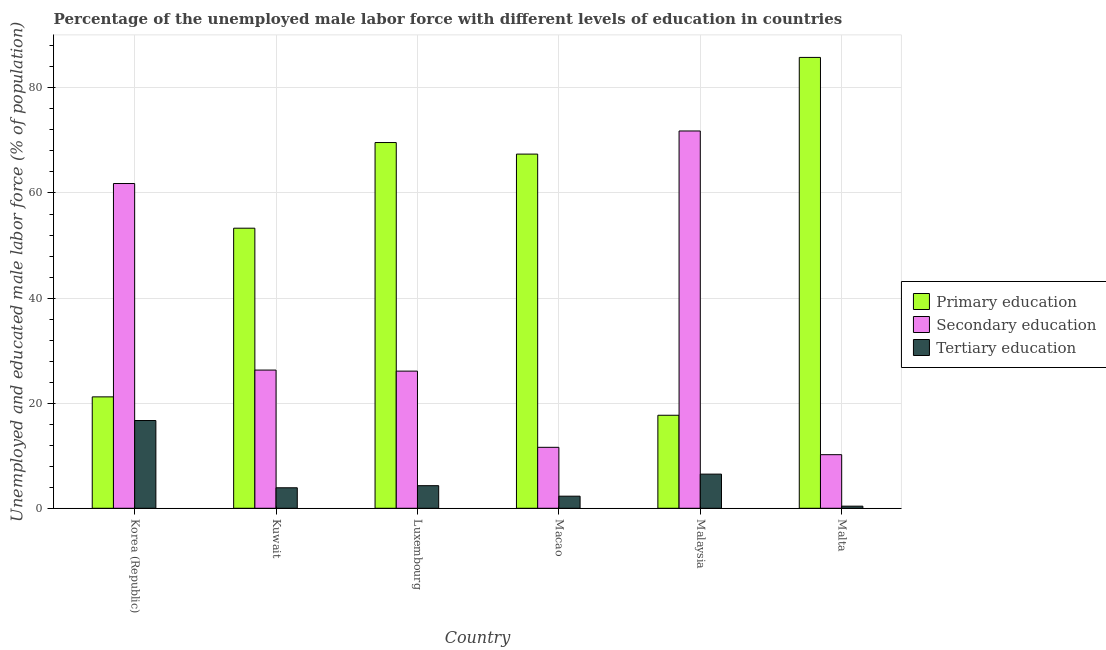How many different coloured bars are there?
Keep it short and to the point. 3. How many groups of bars are there?
Make the answer very short. 6. How many bars are there on the 1st tick from the left?
Your answer should be very brief. 3. What is the label of the 4th group of bars from the left?
Your answer should be compact. Macao. What is the percentage of male labor force who received secondary education in Malaysia?
Your response must be concise. 71.8. Across all countries, what is the maximum percentage of male labor force who received primary education?
Provide a succinct answer. 85.8. Across all countries, what is the minimum percentage of male labor force who received primary education?
Ensure brevity in your answer.  17.7. In which country was the percentage of male labor force who received tertiary education maximum?
Make the answer very short. Korea (Republic). In which country was the percentage of male labor force who received primary education minimum?
Make the answer very short. Malaysia. What is the total percentage of male labor force who received primary education in the graph?
Your response must be concise. 315. What is the difference between the percentage of male labor force who received tertiary education in Korea (Republic) and that in Malta?
Offer a terse response. 16.3. What is the difference between the percentage of male labor force who received tertiary education in Luxembourg and the percentage of male labor force who received secondary education in Korea (Republic)?
Ensure brevity in your answer.  -57.5. What is the average percentage of male labor force who received secondary education per country?
Your answer should be very brief. 34.63. What is the difference between the percentage of male labor force who received secondary education and percentage of male labor force who received primary education in Malta?
Keep it short and to the point. -75.6. What is the ratio of the percentage of male labor force who received secondary education in Macao to that in Malaysia?
Give a very brief answer. 0.16. Is the percentage of male labor force who received secondary education in Korea (Republic) less than that in Malaysia?
Your answer should be compact. Yes. Is the difference between the percentage of male labor force who received tertiary education in Kuwait and Malaysia greater than the difference between the percentage of male labor force who received secondary education in Kuwait and Malaysia?
Your answer should be very brief. Yes. What is the difference between the highest and the second highest percentage of male labor force who received primary education?
Make the answer very short. 16.2. What is the difference between the highest and the lowest percentage of male labor force who received primary education?
Offer a very short reply. 68.1. Is the sum of the percentage of male labor force who received tertiary education in Luxembourg and Malta greater than the maximum percentage of male labor force who received primary education across all countries?
Keep it short and to the point. No. What does the 3rd bar from the right in Malta represents?
Your answer should be compact. Primary education. How many bars are there?
Your answer should be very brief. 18. Are all the bars in the graph horizontal?
Keep it short and to the point. No. How many countries are there in the graph?
Your answer should be very brief. 6. What is the difference between two consecutive major ticks on the Y-axis?
Ensure brevity in your answer.  20. Are the values on the major ticks of Y-axis written in scientific E-notation?
Offer a very short reply. No. What is the title of the graph?
Provide a succinct answer. Percentage of the unemployed male labor force with different levels of education in countries. What is the label or title of the X-axis?
Offer a very short reply. Country. What is the label or title of the Y-axis?
Your answer should be very brief. Unemployed and educated male labor force (% of population). What is the Unemployed and educated male labor force (% of population) of Primary education in Korea (Republic)?
Offer a very short reply. 21.2. What is the Unemployed and educated male labor force (% of population) of Secondary education in Korea (Republic)?
Give a very brief answer. 61.8. What is the Unemployed and educated male labor force (% of population) of Tertiary education in Korea (Republic)?
Offer a very short reply. 16.7. What is the Unemployed and educated male labor force (% of population) of Primary education in Kuwait?
Give a very brief answer. 53.3. What is the Unemployed and educated male labor force (% of population) of Secondary education in Kuwait?
Ensure brevity in your answer.  26.3. What is the Unemployed and educated male labor force (% of population) in Tertiary education in Kuwait?
Make the answer very short. 3.9. What is the Unemployed and educated male labor force (% of population) of Primary education in Luxembourg?
Provide a succinct answer. 69.6. What is the Unemployed and educated male labor force (% of population) in Secondary education in Luxembourg?
Your answer should be very brief. 26.1. What is the Unemployed and educated male labor force (% of population) in Tertiary education in Luxembourg?
Your answer should be compact. 4.3. What is the Unemployed and educated male labor force (% of population) in Primary education in Macao?
Your response must be concise. 67.4. What is the Unemployed and educated male labor force (% of population) in Secondary education in Macao?
Ensure brevity in your answer.  11.6. What is the Unemployed and educated male labor force (% of population) in Tertiary education in Macao?
Ensure brevity in your answer.  2.3. What is the Unemployed and educated male labor force (% of population) of Primary education in Malaysia?
Give a very brief answer. 17.7. What is the Unemployed and educated male labor force (% of population) in Secondary education in Malaysia?
Offer a very short reply. 71.8. What is the Unemployed and educated male labor force (% of population) of Tertiary education in Malaysia?
Ensure brevity in your answer.  6.5. What is the Unemployed and educated male labor force (% of population) in Primary education in Malta?
Make the answer very short. 85.8. What is the Unemployed and educated male labor force (% of population) of Secondary education in Malta?
Offer a very short reply. 10.2. What is the Unemployed and educated male labor force (% of population) of Tertiary education in Malta?
Make the answer very short. 0.4. Across all countries, what is the maximum Unemployed and educated male labor force (% of population) of Primary education?
Offer a very short reply. 85.8. Across all countries, what is the maximum Unemployed and educated male labor force (% of population) in Secondary education?
Your answer should be compact. 71.8. Across all countries, what is the maximum Unemployed and educated male labor force (% of population) in Tertiary education?
Make the answer very short. 16.7. Across all countries, what is the minimum Unemployed and educated male labor force (% of population) in Primary education?
Your answer should be very brief. 17.7. Across all countries, what is the minimum Unemployed and educated male labor force (% of population) in Secondary education?
Provide a short and direct response. 10.2. Across all countries, what is the minimum Unemployed and educated male labor force (% of population) in Tertiary education?
Your answer should be very brief. 0.4. What is the total Unemployed and educated male labor force (% of population) of Primary education in the graph?
Make the answer very short. 315. What is the total Unemployed and educated male labor force (% of population) of Secondary education in the graph?
Your response must be concise. 207.8. What is the total Unemployed and educated male labor force (% of population) of Tertiary education in the graph?
Offer a very short reply. 34.1. What is the difference between the Unemployed and educated male labor force (% of population) in Primary education in Korea (Republic) and that in Kuwait?
Keep it short and to the point. -32.1. What is the difference between the Unemployed and educated male labor force (% of population) in Secondary education in Korea (Republic) and that in Kuwait?
Keep it short and to the point. 35.5. What is the difference between the Unemployed and educated male labor force (% of population) in Primary education in Korea (Republic) and that in Luxembourg?
Give a very brief answer. -48.4. What is the difference between the Unemployed and educated male labor force (% of population) in Secondary education in Korea (Republic) and that in Luxembourg?
Ensure brevity in your answer.  35.7. What is the difference between the Unemployed and educated male labor force (% of population) of Tertiary education in Korea (Republic) and that in Luxembourg?
Your response must be concise. 12.4. What is the difference between the Unemployed and educated male labor force (% of population) in Primary education in Korea (Republic) and that in Macao?
Provide a succinct answer. -46.2. What is the difference between the Unemployed and educated male labor force (% of population) in Secondary education in Korea (Republic) and that in Macao?
Give a very brief answer. 50.2. What is the difference between the Unemployed and educated male labor force (% of population) in Tertiary education in Korea (Republic) and that in Macao?
Provide a short and direct response. 14.4. What is the difference between the Unemployed and educated male labor force (% of population) of Primary education in Korea (Republic) and that in Malaysia?
Offer a very short reply. 3.5. What is the difference between the Unemployed and educated male labor force (% of population) of Secondary education in Korea (Republic) and that in Malaysia?
Offer a terse response. -10. What is the difference between the Unemployed and educated male labor force (% of population) of Tertiary education in Korea (Republic) and that in Malaysia?
Your answer should be compact. 10.2. What is the difference between the Unemployed and educated male labor force (% of population) of Primary education in Korea (Republic) and that in Malta?
Offer a very short reply. -64.6. What is the difference between the Unemployed and educated male labor force (% of population) of Secondary education in Korea (Republic) and that in Malta?
Offer a very short reply. 51.6. What is the difference between the Unemployed and educated male labor force (% of population) in Primary education in Kuwait and that in Luxembourg?
Provide a short and direct response. -16.3. What is the difference between the Unemployed and educated male labor force (% of population) in Secondary education in Kuwait and that in Luxembourg?
Offer a very short reply. 0.2. What is the difference between the Unemployed and educated male labor force (% of population) of Primary education in Kuwait and that in Macao?
Provide a short and direct response. -14.1. What is the difference between the Unemployed and educated male labor force (% of population) in Secondary education in Kuwait and that in Macao?
Give a very brief answer. 14.7. What is the difference between the Unemployed and educated male labor force (% of population) of Primary education in Kuwait and that in Malaysia?
Make the answer very short. 35.6. What is the difference between the Unemployed and educated male labor force (% of population) in Secondary education in Kuwait and that in Malaysia?
Offer a very short reply. -45.5. What is the difference between the Unemployed and educated male labor force (% of population) in Primary education in Kuwait and that in Malta?
Offer a terse response. -32.5. What is the difference between the Unemployed and educated male labor force (% of population) of Primary education in Luxembourg and that in Malaysia?
Give a very brief answer. 51.9. What is the difference between the Unemployed and educated male labor force (% of population) of Secondary education in Luxembourg and that in Malaysia?
Give a very brief answer. -45.7. What is the difference between the Unemployed and educated male labor force (% of population) in Primary education in Luxembourg and that in Malta?
Your answer should be compact. -16.2. What is the difference between the Unemployed and educated male labor force (% of population) in Secondary education in Luxembourg and that in Malta?
Keep it short and to the point. 15.9. What is the difference between the Unemployed and educated male labor force (% of population) in Tertiary education in Luxembourg and that in Malta?
Your answer should be very brief. 3.9. What is the difference between the Unemployed and educated male labor force (% of population) of Primary education in Macao and that in Malaysia?
Make the answer very short. 49.7. What is the difference between the Unemployed and educated male labor force (% of population) of Secondary education in Macao and that in Malaysia?
Make the answer very short. -60.2. What is the difference between the Unemployed and educated male labor force (% of population) of Primary education in Macao and that in Malta?
Keep it short and to the point. -18.4. What is the difference between the Unemployed and educated male labor force (% of population) of Tertiary education in Macao and that in Malta?
Keep it short and to the point. 1.9. What is the difference between the Unemployed and educated male labor force (% of population) in Primary education in Malaysia and that in Malta?
Provide a short and direct response. -68.1. What is the difference between the Unemployed and educated male labor force (% of population) of Secondary education in Malaysia and that in Malta?
Ensure brevity in your answer.  61.6. What is the difference between the Unemployed and educated male labor force (% of population) in Primary education in Korea (Republic) and the Unemployed and educated male labor force (% of population) in Secondary education in Kuwait?
Offer a terse response. -5.1. What is the difference between the Unemployed and educated male labor force (% of population) of Primary education in Korea (Republic) and the Unemployed and educated male labor force (% of population) of Tertiary education in Kuwait?
Your response must be concise. 17.3. What is the difference between the Unemployed and educated male labor force (% of population) of Secondary education in Korea (Republic) and the Unemployed and educated male labor force (% of population) of Tertiary education in Kuwait?
Keep it short and to the point. 57.9. What is the difference between the Unemployed and educated male labor force (% of population) of Secondary education in Korea (Republic) and the Unemployed and educated male labor force (% of population) of Tertiary education in Luxembourg?
Provide a succinct answer. 57.5. What is the difference between the Unemployed and educated male labor force (% of population) in Primary education in Korea (Republic) and the Unemployed and educated male labor force (% of population) in Secondary education in Macao?
Give a very brief answer. 9.6. What is the difference between the Unemployed and educated male labor force (% of population) in Primary education in Korea (Republic) and the Unemployed and educated male labor force (% of population) in Tertiary education in Macao?
Ensure brevity in your answer.  18.9. What is the difference between the Unemployed and educated male labor force (% of population) of Secondary education in Korea (Republic) and the Unemployed and educated male labor force (% of population) of Tertiary education in Macao?
Ensure brevity in your answer.  59.5. What is the difference between the Unemployed and educated male labor force (% of population) in Primary education in Korea (Republic) and the Unemployed and educated male labor force (% of population) in Secondary education in Malaysia?
Give a very brief answer. -50.6. What is the difference between the Unemployed and educated male labor force (% of population) in Primary education in Korea (Republic) and the Unemployed and educated male labor force (% of population) in Tertiary education in Malaysia?
Your answer should be very brief. 14.7. What is the difference between the Unemployed and educated male labor force (% of population) of Secondary education in Korea (Republic) and the Unemployed and educated male labor force (% of population) of Tertiary education in Malaysia?
Provide a succinct answer. 55.3. What is the difference between the Unemployed and educated male labor force (% of population) in Primary education in Korea (Republic) and the Unemployed and educated male labor force (% of population) in Tertiary education in Malta?
Offer a very short reply. 20.8. What is the difference between the Unemployed and educated male labor force (% of population) of Secondary education in Korea (Republic) and the Unemployed and educated male labor force (% of population) of Tertiary education in Malta?
Ensure brevity in your answer.  61.4. What is the difference between the Unemployed and educated male labor force (% of population) of Primary education in Kuwait and the Unemployed and educated male labor force (% of population) of Secondary education in Luxembourg?
Give a very brief answer. 27.2. What is the difference between the Unemployed and educated male labor force (% of population) of Secondary education in Kuwait and the Unemployed and educated male labor force (% of population) of Tertiary education in Luxembourg?
Give a very brief answer. 22. What is the difference between the Unemployed and educated male labor force (% of population) in Primary education in Kuwait and the Unemployed and educated male labor force (% of population) in Secondary education in Macao?
Your answer should be compact. 41.7. What is the difference between the Unemployed and educated male labor force (% of population) of Primary education in Kuwait and the Unemployed and educated male labor force (% of population) of Secondary education in Malaysia?
Keep it short and to the point. -18.5. What is the difference between the Unemployed and educated male labor force (% of population) in Primary education in Kuwait and the Unemployed and educated male labor force (% of population) in Tertiary education in Malaysia?
Keep it short and to the point. 46.8. What is the difference between the Unemployed and educated male labor force (% of population) of Secondary education in Kuwait and the Unemployed and educated male labor force (% of population) of Tertiary education in Malaysia?
Offer a terse response. 19.8. What is the difference between the Unemployed and educated male labor force (% of population) of Primary education in Kuwait and the Unemployed and educated male labor force (% of population) of Secondary education in Malta?
Your answer should be compact. 43.1. What is the difference between the Unemployed and educated male labor force (% of population) of Primary education in Kuwait and the Unemployed and educated male labor force (% of population) of Tertiary education in Malta?
Make the answer very short. 52.9. What is the difference between the Unemployed and educated male labor force (% of population) of Secondary education in Kuwait and the Unemployed and educated male labor force (% of population) of Tertiary education in Malta?
Make the answer very short. 25.9. What is the difference between the Unemployed and educated male labor force (% of population) of Primary education in Luxembourg and the Unemployed and educated male labor force (% of population) of Secondary education in Macao?
Offer a terse response. 58. What is the difference between the Unemployed and educated male labor force (% of population) in Primary education in Luxembourg and the Unemployed and educated male labor force (% of population) in Tertiary education in Macao?
Offer a terse response. 67.3. What is the difference between the Unemployed and educated male labor force (% of population) of Secondary education in Luxembourg and the Unemployed and educated male labor force (% of population) of Tertiary education in Macao?
Offer a very short reply. 23.8. What is the difference between the Unemployed and educated male labor force (% of population) in Primary education in Luxembourg and the Unemployed and educated male labor force (% of population) in Secondary education in Malaysia?
Provide a succinct answer. -2.2. What is the difference between the Unemployed and educated male labor force (% of population) in Primary education in Luxembourg and the Unemployed and educated male labor force (% of population) in Tertiary education in Malaysia?
Ensure brevity in your answer.  63.1. What is the difference between the Unemployed and educated male labor force (% of population) in Secondary education in Luxembourg and the Unemployed and educated male labor force (% of population) in Tertiary education in Malaysia?
Your response must be concise. 19.6. What is the difference between the Unemployed and educated male labor force (% of population) in Primary education in Luxembourg and the Unemployed and educated male labor force (% of population) in Secondary education in Malta?
Provide a succinct answer. 59.4. What is the difference between the Unemployed and educated male labor force (% of population) in Primary education in Luxembourg and the Unemployed and educated male labor force (% of population) in Tertiary education in Malta?
Provide a short and direct response. 69.2. What is the difference between the Unemployed and educated male labor force (% of population) in Secondary education in Luxembourg and the Unemployed and educated male labor force (% of population) in Tertiary education in Malta?
Keep it short and to the point. 25.7. What is the difference between the Unemployed and educated male labor force (% of population) in Primary education in Macao and the Unemployed and educated male labor force (% of population) in Tertiary education in Malaysia?
Offer a very short reply. 60.9. What is the difference between the Unemployed and educated male labor force (% of population) of Primary education in Macao and the Unemployed and educated male labor force (% of population) of Secondary education in Malta?
Your answer should be compact. 57.2. What is the difference between the Unemployed and educated male labor force (% of population) of Secondary education in Malaysia and the Unemployed and educated male labor force (% of population) of Tertiary education in Malta?
Make the answer very short. 71.4. What is the average Unemployed and educated male labor force (% of population) of Primary education per country?
Make the answer very short. 52.5. What is the average Unemployed and educated male labor force (% of population) in Secondary education per country?
Offer a very short reply. 34.63. What is the average Unemployed and educated male labor force (% of population) of Tertiary education per country?
Your answer should be very brief. 5.68. What is the difference between the Unemployed and educated male labor force (% of population) in Primary education and Unemployed and educated male labor force (% of population) in Secondary education in Korea (Republic)?
Offer a very short reply. -40.6. What is the difference between the Unemployed and educated male labor force (% of population) in Secondary education and Unemployed and educated male labor force (% of population) in Tertiary education in Korea (Republic)?
Provide a short and direct response. 45.1. What is the difference between the Unemployed and educated male labor force (% of population) in Primary education and Unemployed and educated male labor force (% of population) in Tertiary education in Kuwait?
Provide a succinct answer. 49.4. What is the difference between the Unemployed and educated male labor force (% of population) in Secondary education and Unemployed and educated male labor force (% of population) in Tertiary education in Kuwait?
Your answer should be very brief. 22.4. What is the difference between the Unemployed and educated male labor force (% of population) in Primary education and Unemployed and educated male labor force (% of population) in Secondary education in Luxembourg?
Offer a terse response. 43.5. What is the difference between the Unemployed and educated male labor force (% of population) in Primary education and Unemployed and educated male labor force (% of population) in Tertiary education in Luxembourg?
Make the answer very short. 65.3. What is the difference between the Unemployed and educated male labor force (% of population) of Secondary education and Unemployed and educated male labor force (% of population) of Tertiary education in Luxembourg?
Make the answer very short. 21.8. What is the difference between the Unemployed and educated male labor force (% of population) of Primary education and Unemployed and educated male labor force (% of population) of Secondary education in Macao?
Give a very brief answer. 55.8. What is the difference between the Unemployed and educated male labor force (% of population) of Primary education and Unemployed and educated male labor force (% of population) of Tertiary education in Macao?
Your answer should be compact. 65.1. What is the difference between the Unemployed and educated male labor force (% of population) in Primary education and Unemployed and educated male labor force (% of population) in Secondary education in Malaysia?
Offer a terse response. -54.1. What is the difference between the Unemployed and educated male labor force (% of population) of Secondary education and Unemployed and educated male labor force (% of population) of Tertiary education in Malaysia?
Ensure brevity in your answer.  65.3. What is the difference between the Unemployed and educated male labor force (% of population) of Primary education and Unemployed and educated male labor force (% of population) of Secondary education in Malta?
Your answer should be very brief. 75.6. What is the difference between the Unemployed and educated male labor force (% of population) in Primary education and Unemployed and educated male labor force (% of population) in Tertiary education in Malta?
Offer a terse response. 85.4. What is the ratio of the Unemployed and educated male labor force (% of population) of Primary education in Korea (Republic) to that in Kuwait?
Ensure brevity in your answer.  0.4. What is the ratio of the Unemployed and educated male labor force (% of population) in Secondary education in Korea (Republic) to that in Kuwait?
Provide a succinct answer. 2.35. What is the ratio of the Unemployed and educated male labor force (% of population) of Tertiary education in Korea (Republic) to that in Kuwait?
Offer a very short reply. 4.28. What is the ratio of the Unemployed and educated male labor force (% of population) in Primary education in Korea (Republic) to that in Luxembourg?
Your response must be concise. 0.3. What is the ratio of the Unemployed and educated male labor force (% of population) in Secondary education in Korea (Republic) to that in Luxembourg?
Your answer should be compact. 2.37. What is the ratio of the Unemployed and educated male labor force (% of population) in Tertiary education in Korea (Republic) to that in Luxembourg?
Give a very brief answer. 3.88. What is the ratio of the Unemployed and educated male labor force (% of population) in Primary education in Korea (Republic) to that in Macao?
Ensure brevity in your answer.  0.31. What is the ratio of the Unemployed and educated male labor force (% of population) in Secondary education in Korea (Republic) to that in Macao?
Your answer should be very brief. 5.33. What is the ratio of the Unemployed and educated male labor force (% of population) in Tertiary education in Korea (Republic) to that in Macao?
Your answer should be compact. 7.26. What is the ratio of the Unemployed and educated male labor force (% of population) in Primary education in Korea (Republic) to that in Malaysia?
Make the answer very short. 1.2. What is the ratio of the Unemployed and educated male labor force (% of population) of Secondary education in Korea (Republic) to that in Malaysia?
Provide a succinct answer. 0.86. What is the ratio of the Unemployed and educated male labor force (% of population) of Tertiary education in Korea (Republic) to that in Malaysia?
Make the answer very short. 2.57. What is the ratio of the Unemployed and educated male labor force (% of population) of Primary education in Korea (Republic) to that in Malta?
Your answer should be compact. 0.25. What is the ratio of the Unemployed and educated male labor force (% of population) of Secondary education in Korea (Republic) to that in Malta?
Offer a terse response. 6.06. What is the ratio of the Unemployed and educated male labor force (% of population) in Tertiary education in Korea (Republic) to that in Malta?
Provide a succinct answer. 41.75. What is the ratio of the Unemployed and educated male labor force (% of population) of Primary education in Kuwait to that in Luxembourg?
Keep it short and to the point. 0.77. What is the ratio of the Unemployed and educated male labor force (% of population) in Secondary education in Kuwait to that in Luxembourg?
Make the answer very short. 1.01. What is the ratio of the Unemployed and educated male labor force (% of population) of Tertiary education in Kuwait to that in Luxembourg?
Ensure brevity in your answer.  0.91. What is the ratio of the Unemployed and educated male labor force (% of population) of Primary education in Kuwait to that in Macao?
Keep it short and to the point. 0.79. What is the ratio of the Unemployed and educated male labor force (% of population) of Secondary education in Kuwait to that in Macao?
Offer a very short reply. 2.27. What is the ratio of the Unemployed and educated male labor force (% of population) of Tertiary education in Kuwait to that in Macao?
Make the answer very short. 1.7. What is the ratio of the Unemployed and educated male labor force (% of population) of Primary education in Kuwait to that in Malaysia?
Your answer should be compact. 3.01. What is the ratio of the Unemployed and educated male labor force (% of population) in Secondary education in Kuwait to that in Malaysia?
Make the answer very short. 0.37. What is the ratio of the Unemployed and educated male labor force (% of population) of Primary education in Kuwait to that in Malta?
Make the answer very short. 0.62. What is the ratio of the Unemployed and educated male labor force (% of population) of Secondary education in Kuwait to that in Malta?
Give a very brief answer. 2.58. What is the ratio of the Unemployed and educated male labor force (% of population) of Tertiary education in Kuwait to that in Malta?
Ensure brevity in your answer.  9.75. What is the ratio of the Unemployed and educated male labor force (% of population) of Primary education in Luxembourg to that in Macao?
Provide a short and direct response. 1.03. What is the ratio of the Unemployed and educated male labor force (% of population) in Secondary education in Luxembourg to that in Macao?
Make the answer very short. 2.25. What is the ratio of the Unemployed and educated male labor force (% of population) of Tertiary education in Luxembourg to that in Macao?
Provide a succinct answer. 1.87. What is the ratio of the Unemployed and educated male labor force (% of population) of Primary education in Luxembourg to that in Malaysia?
Your answer should be compact. 3.93. What is the ratio of the Unemployed and educated male labor force (% of population) of Secondary education in Luxembourg to that in Malaysia?
Keep it short and to the point. 0.36. What is the ratio of the Unemployed and educated male labor force (% of population) in Tertiary education in Luxembourg to that in Malaysia?
Ensure brevity in your answer.  0.66. What is the ratio of the Unemployed and educated male labor force (% of population) in Primary education in Luxembourg to that in Malta?
Give a very brief answer. 0.81. What is the ratio of the Unemployed and educated male labor force (% of population) in Secondary education in Luxembourg to that in Malta?
Give a very brief answer. 2.56. What is the ratio of the Unemployed and educated male labor force (% of population) of Tertiary education in Luxembourg to that in Malta?
Ensure brevity in your answer.  10.75. What is the ratio of the Unemployed and educated male labor force (% of population) in Primary education in Macao to that in Malaysia?
Provide a succinct answer. 3.81. What is the ratio of the Unemployed and educated male labor force (% of population) of Secondary education in Macao to that in Malaysia?
Provide a short and direct response. 0.16. What is the ratio of the Unemployed and educated male labor force (% of population) of Tertiary education in Macao to that in Malaysia?
Provide a succinct answer. 0.35. What is the ratio of the Unemployed and educated male labor force (% of population) in Primary education in Macao to that in Malta?
Offer a terse response. 0.79. What is the ratio of the Unemployed and educated male labor force (% of population) in Secondary education in Macao to that in Malta?
Give a very brief answer. 1.14. What is the ratio of the Unemployed and educated male labor force (% of population) in Tertiary education in Macao to that in Malta?
Your answer should be compact. 5.75. What is the ratio of the Unemployed and educated male labor force (% of population) in Primary education in Malaysia to that in Malta?
Your response must be concise. 0.21. What is the ratio of the Unemployed and educated male labor force (% of population) in Secondary education in Malaysia to that in Malta?
Provide a short and direct response. 7.04. What is the ratio of the Unemployed and educated male labor force (% of population) of Tertiary education in Malaysia to that in Malta?
Ensure brevity in your answer.  16.25. What is the difference between the highest and the second highest Unemployed and educated male labor force (% of population) of Primary education?
Provide a succinct answer. 16.2. What is the difference between the highest and the second highest Unemployed and educated male labor force (% of population) of Secondary education?
Make the answer very short. 10. What is the difference between the highest and the lowest Unemployed and educated male labor force (% of population) of Primary education?
Offer a terse response. 68.1. What is the difference between the highest and the lowest Unemployed and educated male labor force (% of population) in Secondary education?
Keep it short and to the point. 61.6. 